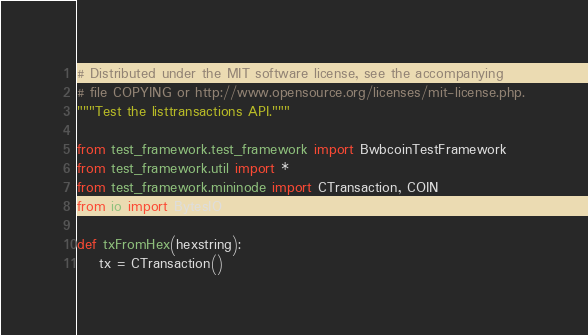Convert code to text. <code><loc_0><loc_0><loc_500><loc_500><_Python_># Distributed under the MIT software license, see the accompanying
# file COPYING or http://www.opensource.org/licenses/mit-license.php.
"""Test the listtransactions API."""

from test_framework.test_framework import BwbcoinTestFramework
from test_framework.util import *
from test_framework.mininode import CTransaction, COIN
from io import BytesIO

def txFromHex(hexstring):
    tx = CTransaction()</code> 